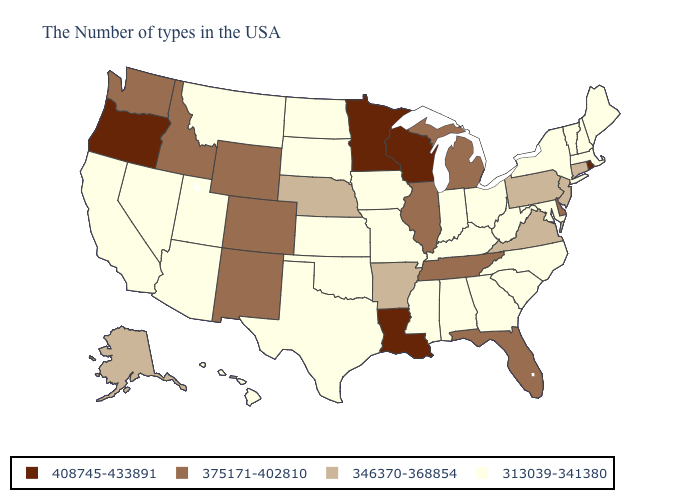Does Minnesota have the highest value in the USA?
Be succinct. Yes. How many symbols are there in the legend?
Short answer required. 4. Name the states that have a value in the range 313039-341380?
Quick response, please. Maine, Massachusetts, New Hampshire, Vermont, New York, Maryland, North Carolina, South Carolina, West Virginia, Ohio, Georgia, Kentucky, Indiana, Alabama, Mississippi, Missouri, Iowa, Kansas, Oklahoma, Texas, South Dakota, North Dakota, Utah, Montana, Arizona, Nevada, California, Hawaii. Does the map have missing data?
Keep it brief. No. Name the states that have a value in the range 408745-433891?
Write a very short answer. Rhode Island, Wisconsin, Louisiana, Minnesota, Oregon. Name the states that have a value in the range 313039-341380?
Short answer required. Maine, Massachusetts, New Hampshire, Vermont, New York, Maryland, North Carolina, South Carolina, West Virginia, Ohio, Georgia, Kentucky, Indiana, Alabama, Mississippi, Missouri, Iowa, Kansas, Oklahoma, Texas, South Dakota, North Dakota, Utah, Montana, Arizona, Nevada, California, Hawaii. Among the states that border North Carolina , does Tennessee have the lowest value?
Concise answer only. No. Does the first symbol in the legend represent the smallest category?
Give a very brief answer. No. Name the states that have a value in the range 375171-402810?
Give a very brief answer. Delaware, Florida, Michigan, Tennessee, Illinois, Wyoming, Colorado, New Mexico, Idaho, Washington. Among the states that border Rhode Island , does Massachusetts have the lowest value?
Concise answer only. Yes. Which states have the lowest value in the West?
Answer briefly. Utah, Montana, Arizona, Nevada, California, Hawaii. What is the value of Hawaii?
Give a very brief answer. 313039-341380. Does Rhode Island have the lowest value in the Northeast?
Write a very short answer. No. What is the highest value in states that border Ohio?
Give a very brief answer. 375171-402810. 